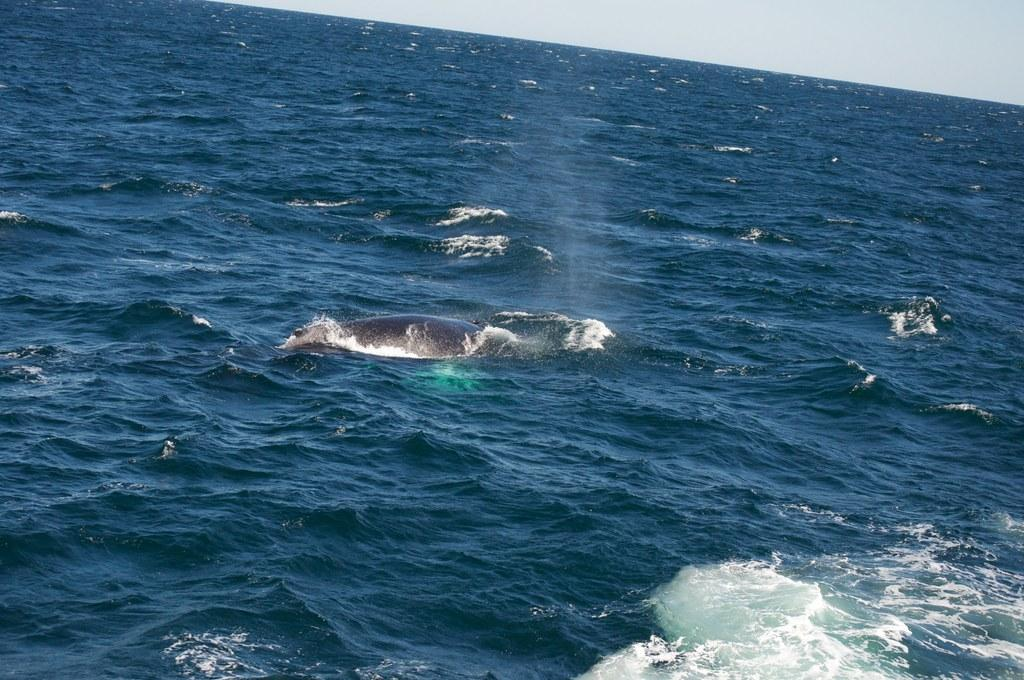What is in the water that is visible in the image? There is a fish in the water. What else can be seen in the image besides the fish? The water and the sky are visible in the image. What type of cable can be seen connecting the fish to the sky in the image? There is no cable connecting the fish to the sky in the image. What song is the fish singing in the image? Fish do not sing songs, and there is no indication of any song being sung in the image. 